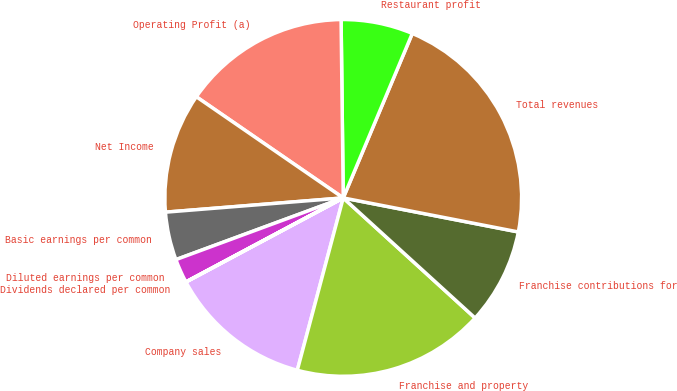Convert chart. <chart><loc_0><loc_0><loc_500><loc_500><pie_chart><fcel>Company sales<fcel>Franchise and property<fcel>Franchise contributions for<fcel>Total revenues<fcel>Restaurant profit<fcel>Operating Profit (a)<fcel>Net Income<fcel>Basic earnings per common<fcel>Diluted earnings per common<fcel>Dividends declared per common<nl><fcel>13.04%<fcel>17.39%<fcel>8.7%<fcel>21.73%<fcel>6.52%<fcel>15.21%<fcel>10.87%<fcel>4.35%<fcel>2.18%<fcel>0.01%<nl></chart> 